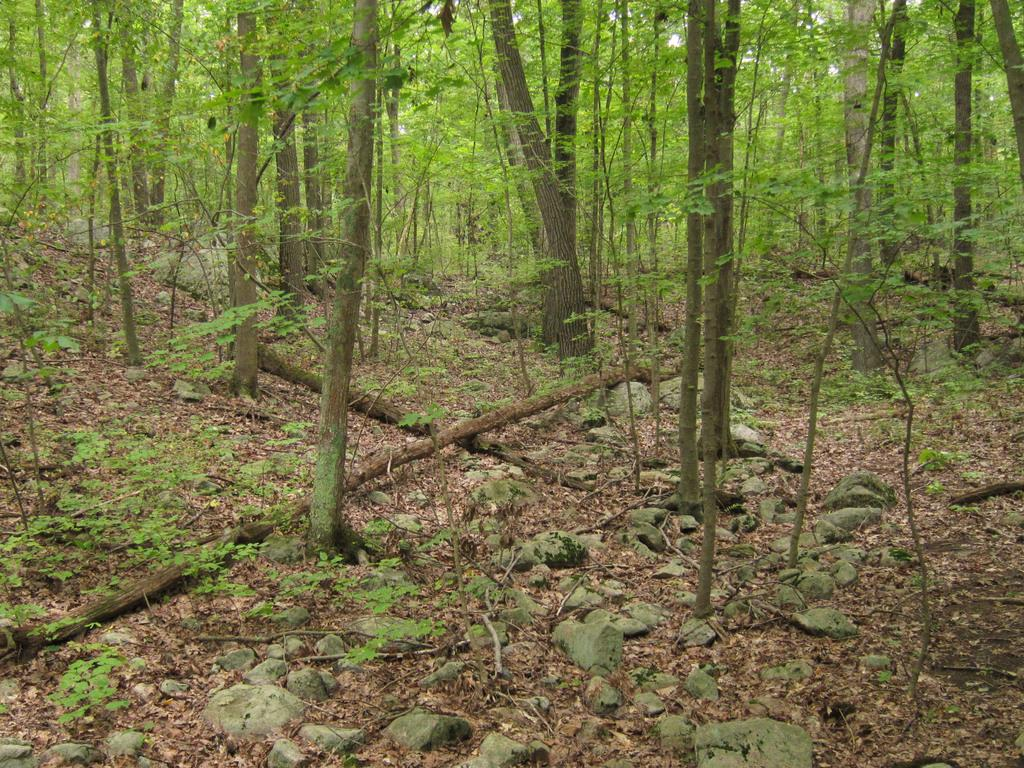What type of vegetation can be seen in the image? There are trees in the image. What objects made of wood can be seen in the image? There are wooden sticks in the image. What type of natural formation can be seen in the image? There are rocks in the image. What type of organic material is present on the surface in the image? Dry leaves are present on the surface in the image. How many sisters are playing with the wooden sticks in the image? There are no sisters present in the image; it only features trees, wooden sticks, rocks, and dry leaves. What type of activity are the sisters performing with the wooden sticks in the image? There are no sisters or wooden sticks rolling in the image; the wooden sticks are stationary. 